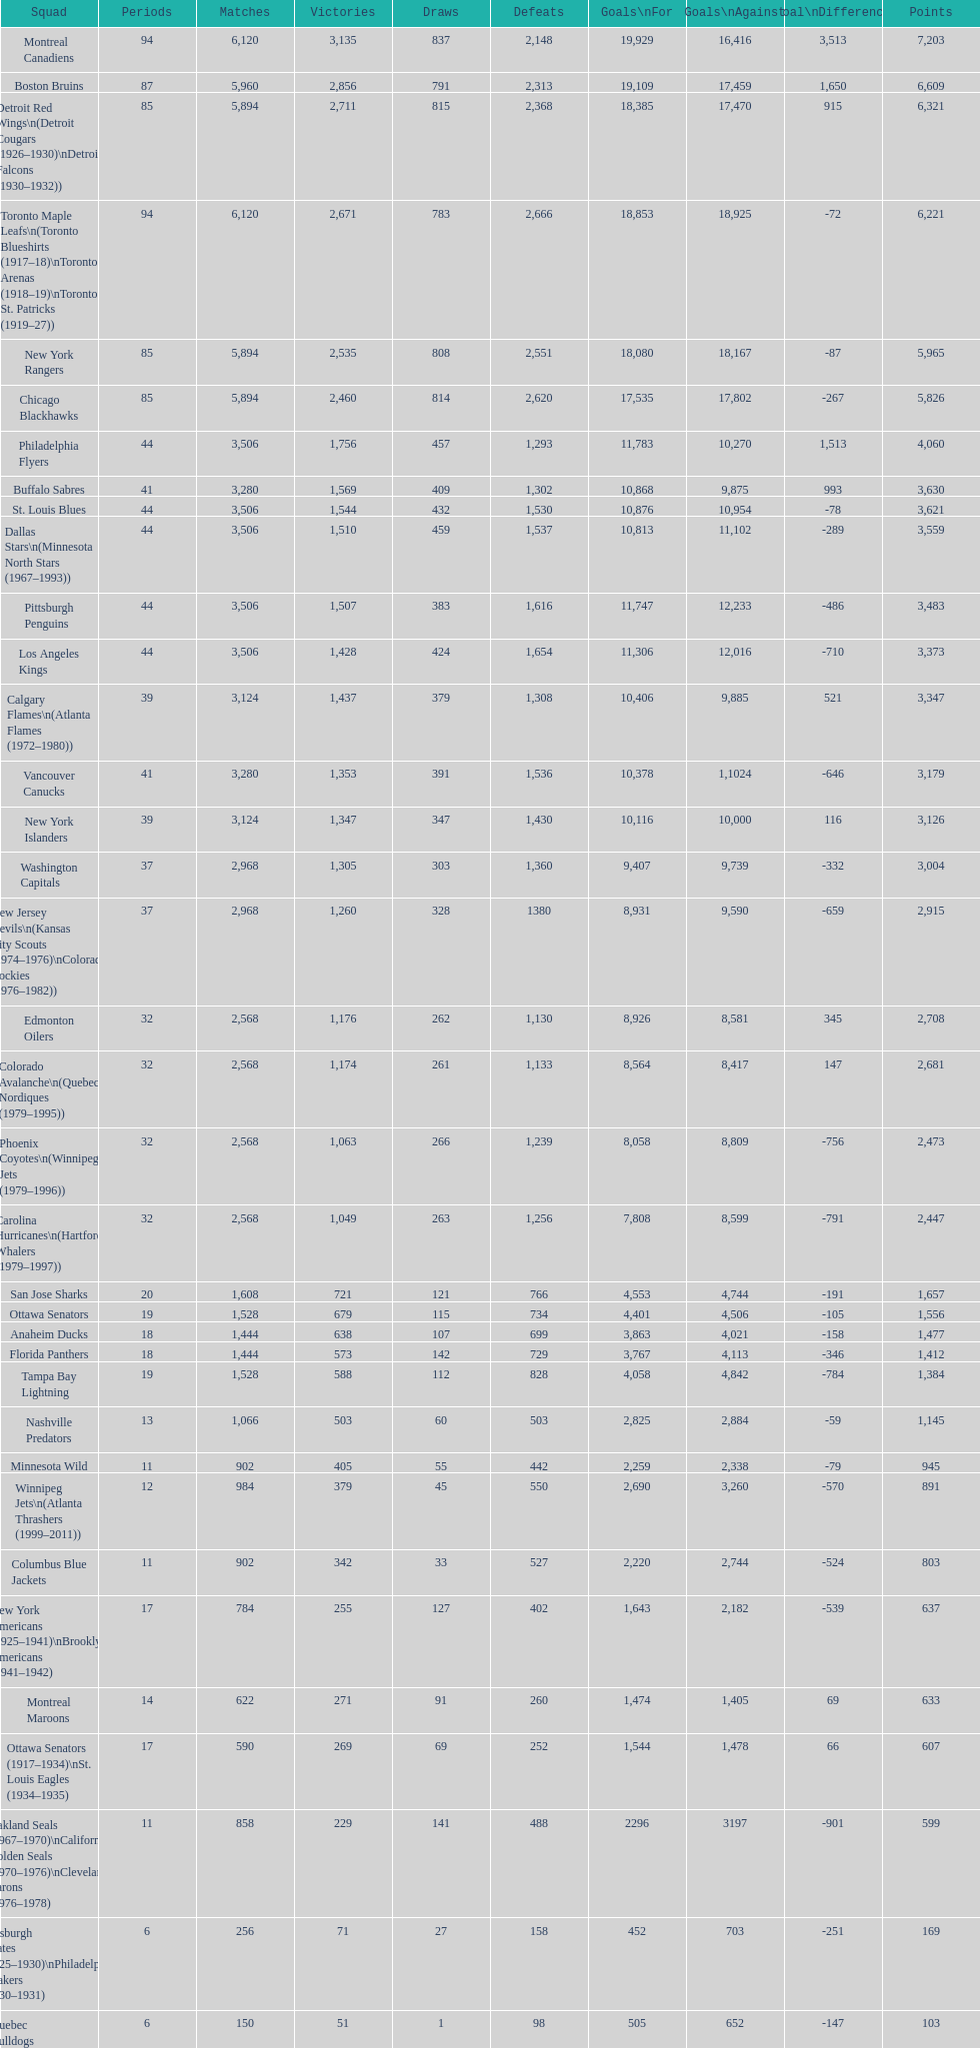Who has the least amount of losses? Montreal Wanderers. 